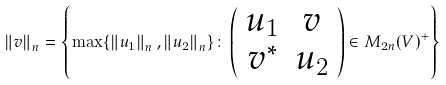Convert formula to latex. <formula><loc_0><loc_0><loc_500><loc_500>\left \| v \right \| _ { n } = \left \{ \max \{ \left \| u _ { 1 } \right \| _ { n } , \left \| u _ { 2 } \right \| _ { n } \} \colon \left ( \begin{array} { c c } u _ { 1 } & v \\ v ^ { * } & u _ { 2 } \end{array} \right ) \in M _ { 2 n } ( V ) ^ { + } \right \}</formula> 